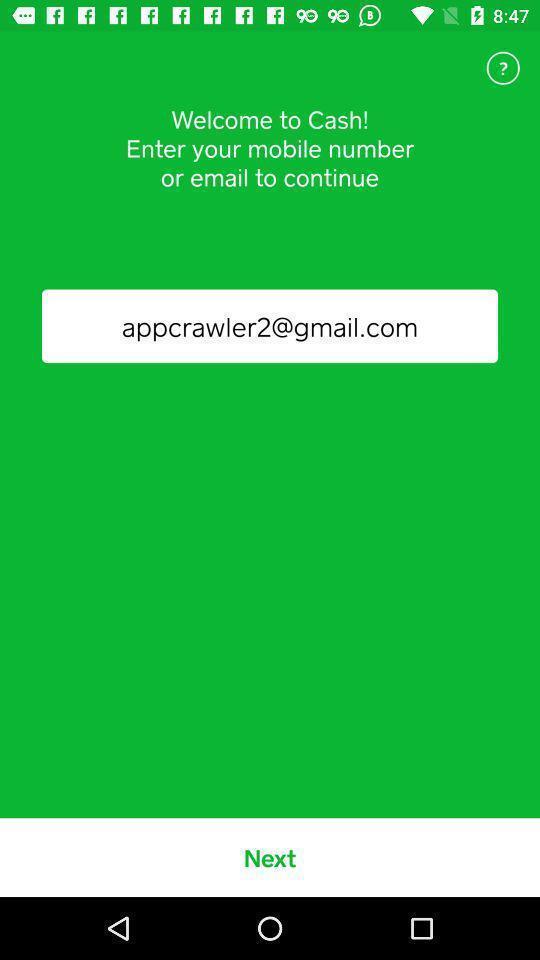Describe the content in this image. Welcome page with option to enter mail address or number. 